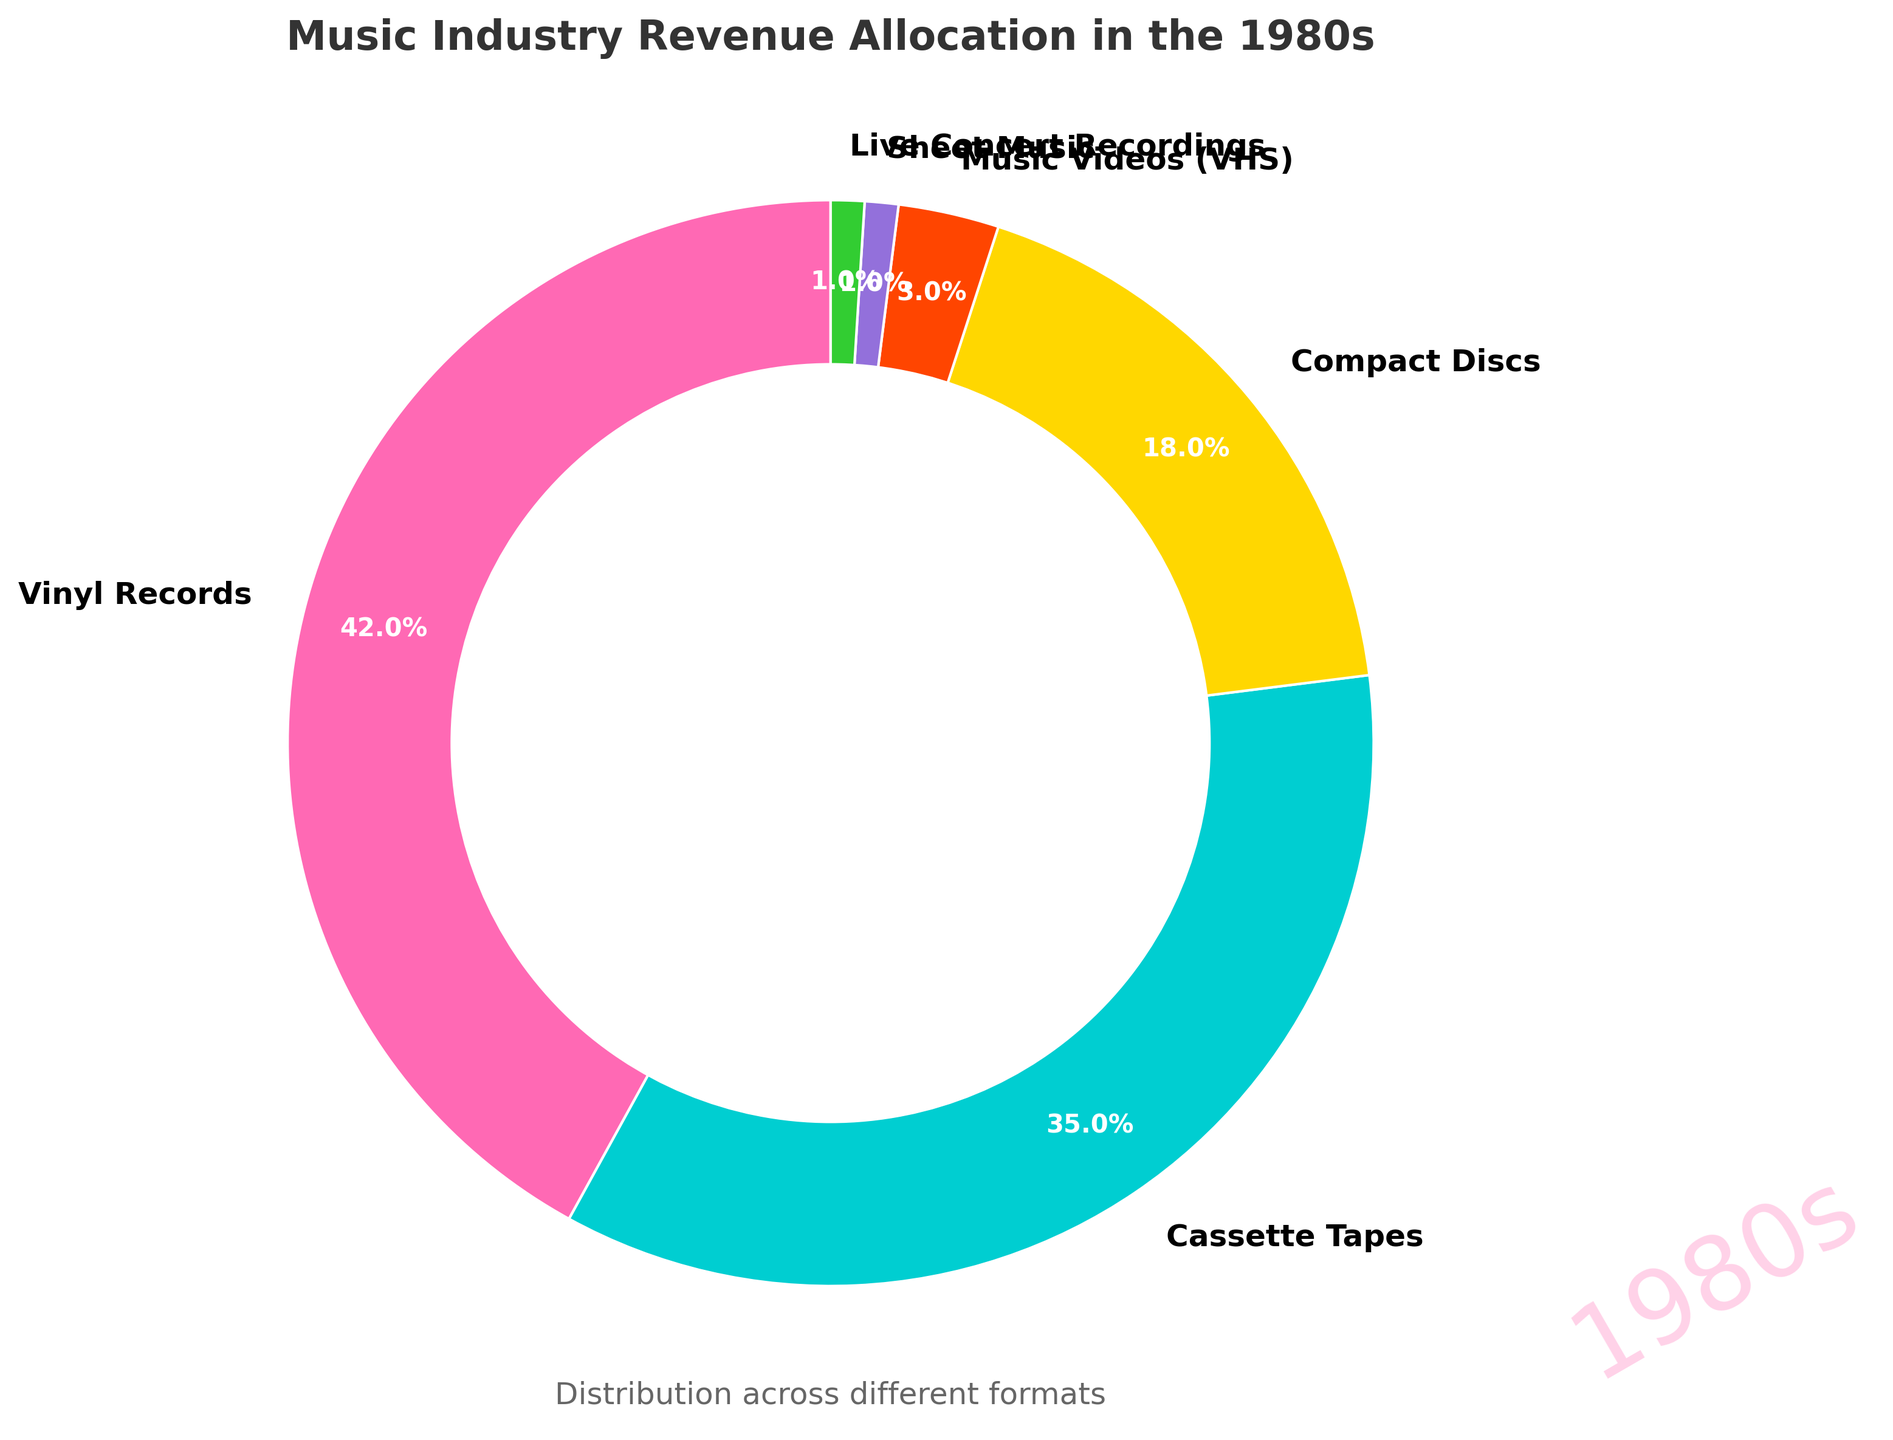What percentage of the total revenue comes from digital formats? By examining the pie chart, we notice that the "Music Videos (VHS)" category represents the closest format to a digital one, accounting for 3%. There are no other digital formats listed for the 1980s. Therefore, the percentage of total revenue from digital formats can be read directly from the slice for "Music Videos (VHS)".
Answer: 3% What is the combined percentage of revenue from vinyl records and cassette tapes? To find the combined percentage of revenue from vinyl records and cassette tapes, sum their individual percentages: 42% (vinyl) + 35% (cassette).
Answer: 77% Which format has the highest revenue allocation? By observing the pie chart, the largest slice corresponds to vinyl records, which represents 42% of the total revenue.
Answer: Vinyl records How much more revenue do vinyl records generate compared to compact discs? To find the difference, subtract the percentage for compact discs (18%) from that of vinyl records (42%). This calculation is 42% - 18%.
Answer: 24% Which formats combined account for less than 5% of the revenue? From the pie chart, the formats with small percentages are "Music Videos (VHS)" at 3%, "Sheet Music" at 1%, and "Live Concert Recordings" at 1%. Adding these values: 3% + 1% + 1% gives us a total of 5%, so these formats account for less than 5% individually.
Answer: Music Videos (VHS), Sheet Music, Live Concert Recordings Is the revenue from compact discs greater or lesser than the combined revenue from sheet music and live concert recordings? The revenue from compact discs is 18%. The combined revenue from sheet music (1%) and live concert recordings (1%) is 1% + 1% = 2%. Since 18% (compact discs) is greater than 2%, the revenue from compact discs is indeed greater.
Answer: Greater Among all formats, which one contributed the least to the revenue? To identify the least contributing formats, look for the smallest slices on the pie chart. Both "Sheet Music" and "Live Concert Recordings" contribute 1% each, which is the smallest value shown.
Answer: Sheet Music and Live Concert Recordings 